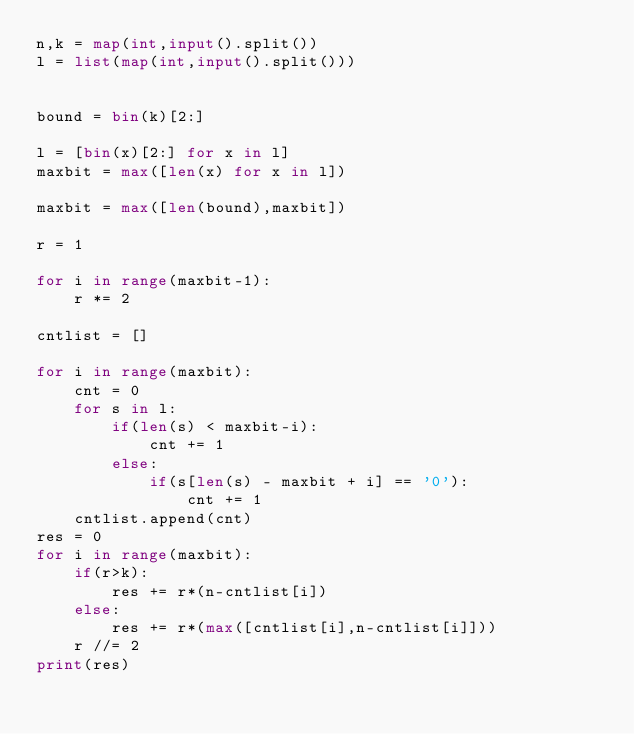Convert code to text. <code><loc_0><loc_0><loc_500><loc_500><_Python_>n,k = map(int,input().split())
l = list(map(int,input().split()))


bound = bin(k)[2:]

l = [bin(x)[2:] for x in l]
maxbit = max([len(x) for x in l])

maxbit = max([len(bound),maxbit])

r = 1

for i in range(maxbit-1):
    r *= 2

cntlist = []

for i in range(maxbit):
    cnt = 0
    for s in l:
        if(len(s) < maxbit-i):
            cnt += 1
        else:
            if(s[len(s) - maxbit + i] == '0'):
                cnt += 1
    cntlist.append(cnt)
res = 0
for i in range(maxbit):
    if(r>k):
        res += r*(n-cntlist[i])
    else:
        res += r*(max([cntlist[i],n-cntlist[i]]))
    r //= 2
print(res)</code> 